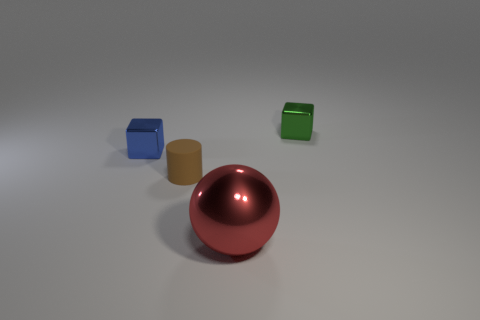Are there an equal number of green objects that are behind the tiny green metallic cube and large gray balls?
Offer a terse response. Yes. Is there another tiny shiny thing of the same shape as the tiny green object?
Offer a terse response. Yes. There is a shiny object that is both behind the big red metal thing and in front of the green cube; what is its shape?
Offer a very short reply. Cube. Is the big red ball made of the same material as the cube right of the blue metal block?
Your answer should be compact. Yes. Are there any objects right of the tiny blue metallic block?
Your response must be concise. Yes. What number of objects are either tiny metal things or big metal balls that are in front of the blue thing?
Your answer should be very brief. 3. The cube that is behind the cube that is on the left side of the small matte thing is what color?
Your response must be concise. Green. What number of other things are the same material as the cylinder?
Offer a very short reply. 0. What number of shiny things are tiny cylinders or small cubes?
Your response must be concise. 2. There is another small thing that is the same shape as the small green object; what is its color?
Offer a terse response. Blue. 